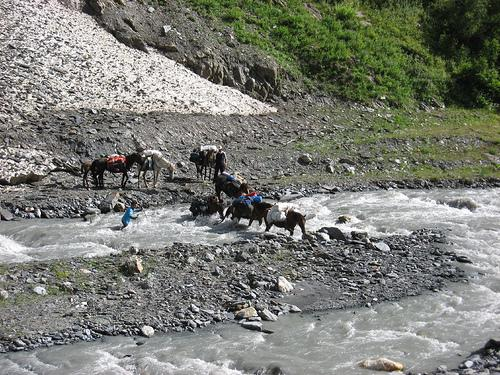What type of terrain is present in the image? A steep rocky hill, grass by the river, and pebbles on the riverbed. Describe any observed interaction between objects in the image. Horses carrying loads are crossing the river, a man is guiding animals, and a person is standing in the water. What are some objects or subjects present in the sky area of the image? There are no objects or subjects mentioned in the sky area of the image. What kind of plants are located near the river? Grass, small green shrubs on a hill, and a group of scrub bushes can be found near the river. How many horses are mentioned in the descriptions and what are they doing? Six horses are mentioned, crossing a river, carrying loads, and gathering together. What can be said about the river and its characteristics? The river is fast-moving, has rocks and pebbles, and there's a person standing in it. What kind of natural formations are in the river? rocks, island of rocks, pebbles, large stone scattered, small pebbles, and river water currents How are the horses positioned around the river? Horses are next to the river, crossing, and some are gathered nearby. Extract the text from the objects in the image and list the colors mentioned. blue, red, black, green, orange Provide a caption for the scene involving a horse with a baby. A brown horse with a baby is crossing the river. How many donkeys are in the scene? None, there are only horses. Identify the attributes of the man who is standing in the river. Wearing a blue shirt and a hat Is there a mountain with snow on top in the image? The captions mention a hill covered in stones and a steep rocky hill, but no mountains with snow are mentioned. A snow-covered mountain would be misleading. Indicate the locations and descriptions of the two horses with packs on their backs. 1) X:105 Y:148 Width:22 Height:22, red and black pack; 2) X:239 Y:190 Width:21 Height:21, blue and red pack What color is the man's hat? Brown Are there any elephants near the river in the image? The captions only mention horses as the primary animals near the river. No elephants are depicted or mentioned. Is there a zebra next to the river in the image? There is no mention of a zebra in any of the captions, only white and brown horses are mentioned. So, a zebra would be misleading. How many horses are in the image? Six horses Is there a white horse in the image? Yes, there is a white horse with its head lowered. Describe the interaction between the man, horses, and the river. The man is guiding the horses across the fast-moving river, and some of them are carrying large loads. Evaluate the quality of the image depicting horses by the river. The image has clear details and well-defined objects. Can you find a green horse near the river? None of the horses mentioned have the color green, so a green horse would be incorrect and misleading. Detect any anomalies present in the image of horses crossing the river. No significant anomalies detected. Identify the sentiment conveyed by the image of horses crossing the river. The sentiment is determination and perseverance. Describe the state of the river. The river is fast-moving, flowing, and has rapidly moving water. Do the horses have any distinctive marks or attributes? Some horses have packs on their backs, and one has an orange blanket. What type of vegetation is found on the hillside? shrubs, bushes, and small green shrubs Is there a woman wearing a red dress at the edge of the river? All the individuals mentioned in the captions are referred to as a man. There is no mention of a woman, and there is no mention of a red dress. Describe the main interaction present with the horses and the river. Horses are crossing the fast-moving river while carrying loads. State the sentiment of the image showing the river and the surrounding environment. The sentiment is peaceful and harmonious. Identify any geographical features present in the image. Hill covered in stones, steep rocky hill, and riverside Do you see a boat sailing down the river in the picture? There is no mention of any boats in any of the captions. The image is focused on horses, a man, and the river, so a boat would be misleading. 